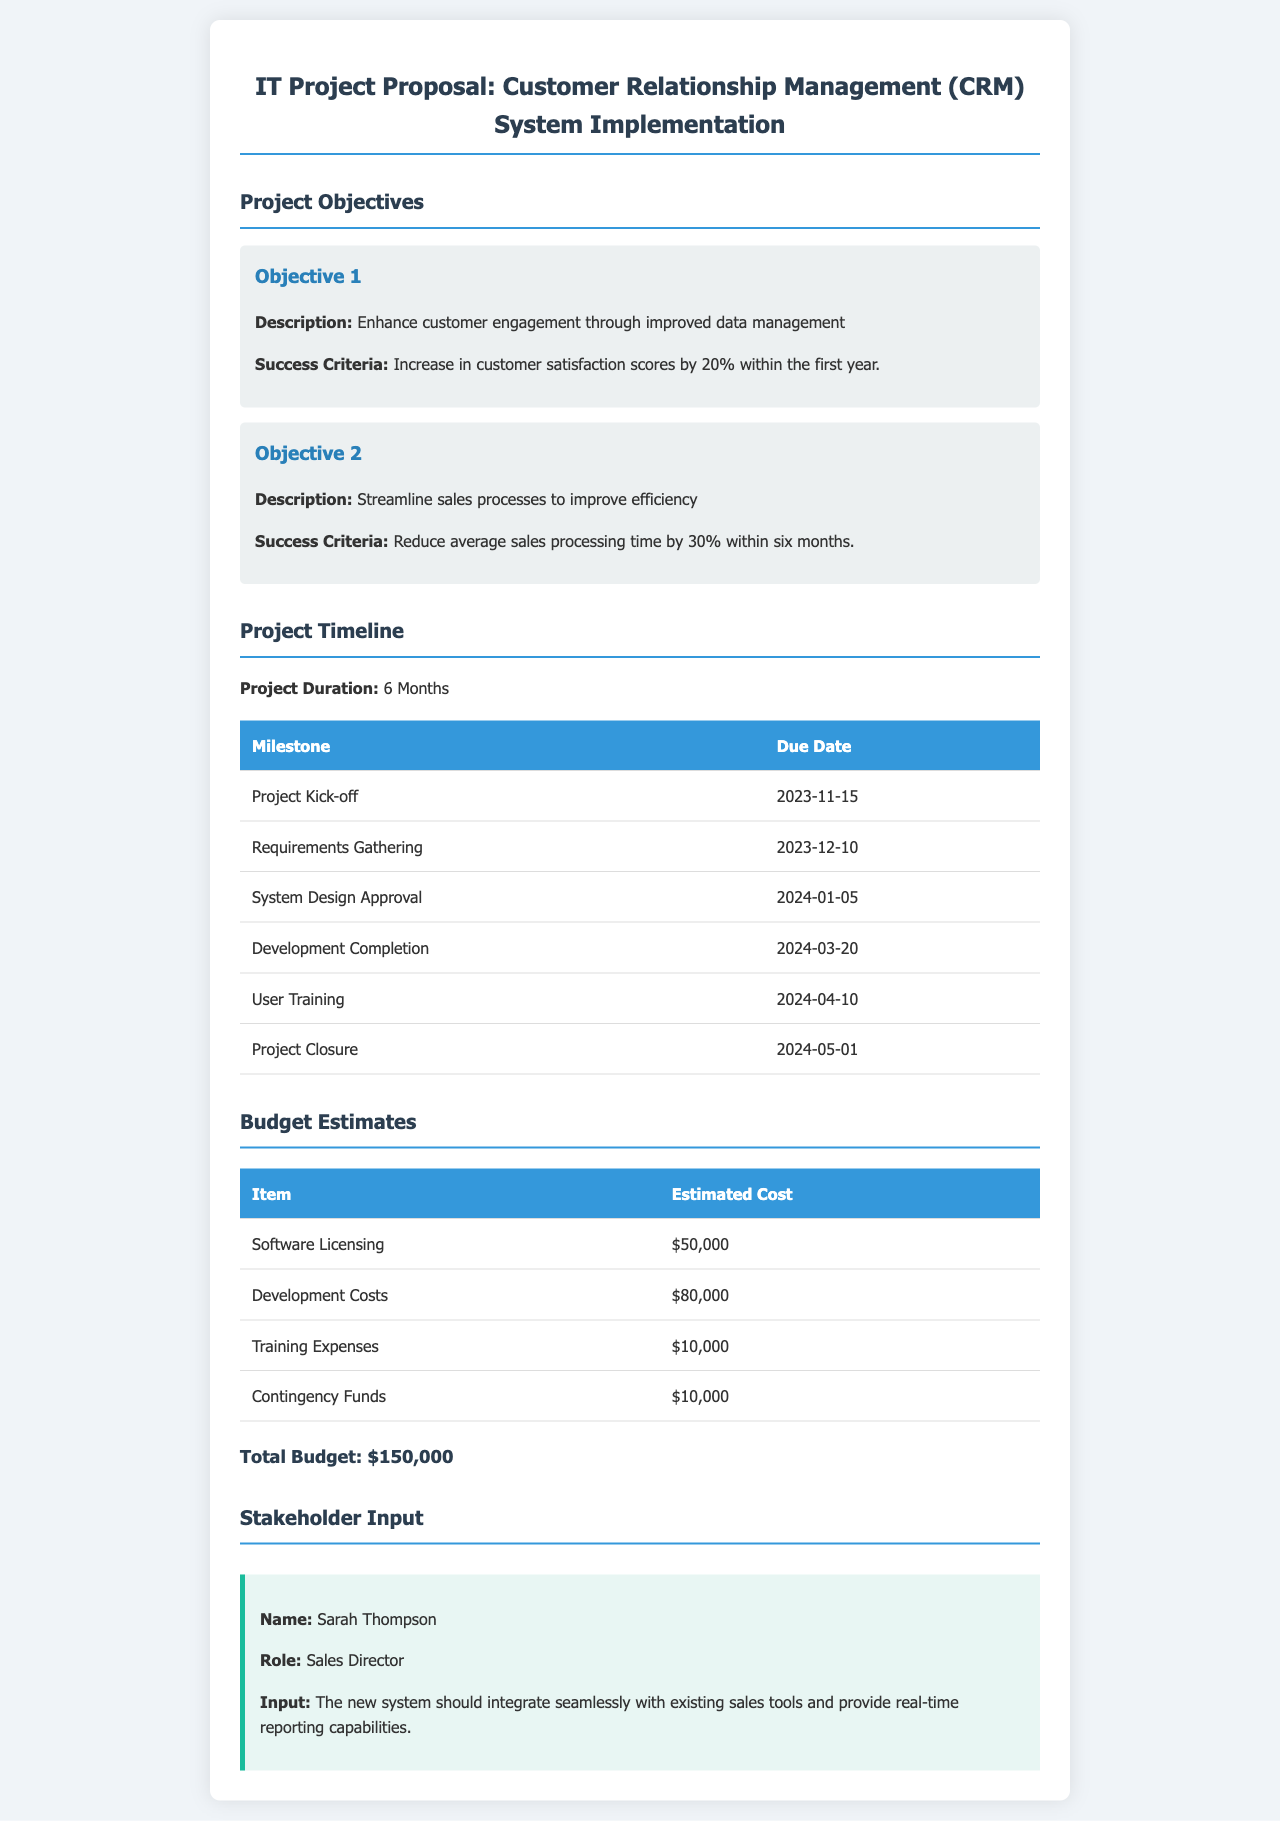What is the title of the project proposal? The title of the project proposal is provided at the top of the document.
Answer: IT Project Proposal: Customer Relationship Management (CRM) System Implementation What is the duration of the project? The project duration is explicitly stated in the project timeline section.
Answer: 6 Months What is the due date for the project kick-off? The due date for the project kick-off can be found in the milestones table.
Answer: 2023-11-15 How much is allocated for software licensing? The estimated cost for software licensing is listed in the budget estimates table.
Answer: $50,000 What increase in customer satisfaction scores is expected? The expected increase in customer satisfaction scores is mentioned in the project objectives section.
Answer: 20% What milestone is due on 2024-01-05? The specific milestone corresponding to this date is detailed in the timeline section.
Answer: System Design Approval What role does Sarah Thompson hold? The role of Sarah Thompson is specified in the stakeholder input section.
Answer: Sales Director What is the total budget estimate for the project? The total budget is clearly summarized at the end of the budget estimates section.
Answer: $150,000 